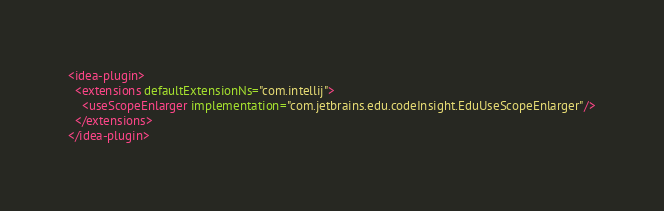Convert code to text. <code><loc_0><loc_0><loc_500><loc_500><_XML_><idea-plugin>
  <extensions defaultExtensionNs="com.intellij">
    <useScopeEnlarger implementation="com.jetbrains.edu.codeInsight.EduUseScopeEnlarger"/>
  </extensions>
</idea-plugin>
</code> 